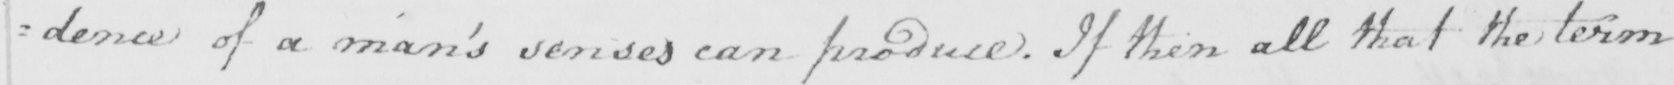Transcribe the text shown in this historical manuscript line. =dence of a man ' s senses can produce . If then all that the term 